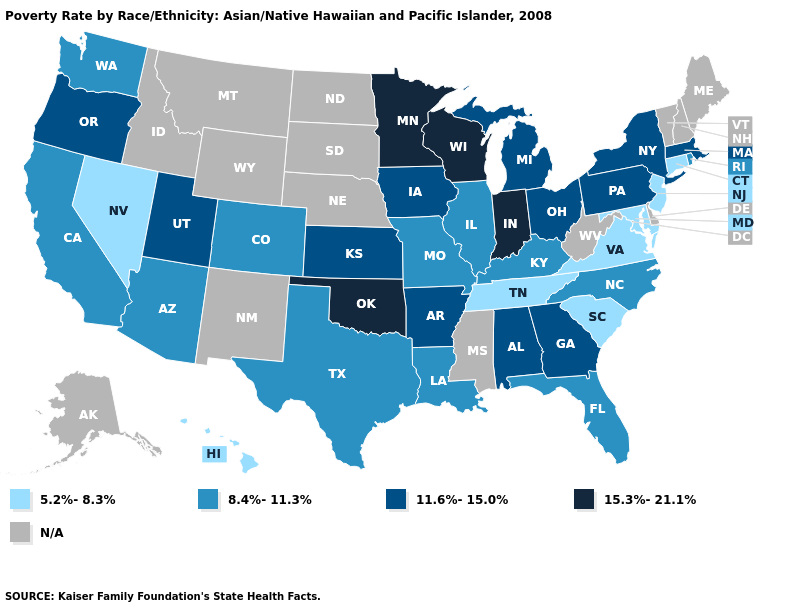What is the highest value in states that border Utah?
Answer briefly. 8.4%-11.3%. Name the states that have a value in the range N/A?
Give a very brief answer. Alaska, Delaware, Idaho, Maine, Mississippi, Montana, Nebraska, New Hampshire, New Mexico, North Dakota, South Dakota, Vermont, West Virginia, Wyoming. Does the map have missing data?
Give a very brief answer. Yes. Name the states that have a value in the range N/A?
Short answer required. Alaska, Delaware, Idaho, Maine, Mississippi, Montana, Nebraska, New Hampshire, New Mexico, North Dakota, South Dakota, Vermont, West Virginia, Wyoming. Among the states that border Connecticut , which have the lowest value?
Be succinct. Rhode Island. What is the value of New Mexico?
Quick response, please. N/A. Is the legend a continuous bar?
Keep it brief. No. Does Oklahoma have the highest value in the South?
Be succinct. Yes. What is the value of Massachusetts?
Write a very short answer. 11.6%-15.0%. Name the states that have a value in the range 5.2%-8.3%?
Give a very brief answer. Connecticut, Hawaii, Maryland, Nevada, New Jersey, South Carolina, Tennessee, Virginia. Name the states that have a value in the range 11.6%-15.0%?
Answer briefly. Alabama, Arkansas, Georgia, Iowa, Kansas, Massachusetts, Michigan, New York, Ohio, Oregon, Pennsylvania, Utah. Does Indiana have the highest value in the USA?
Short answer required. Yes. What is the value of Kentucky?
Short answer required. 8.4%-11.3%. Does Virginia have the highest value in the USA?
Answer briefly. No. 